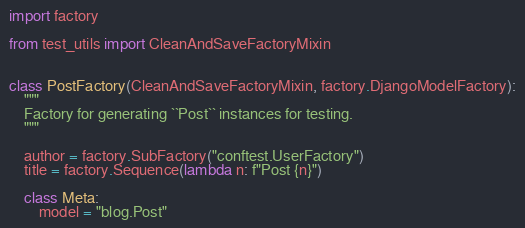<code> <loc_0><loc_0><loc_500><loc_500><_Python_>import factory

from test_utils import CleanAndSaveFactoryMixin


class PostFactory(CleanAndSaveFactoryMixin, factory.DjangoModelFactory):
    """
    Factory for generating ``Post`` instances for testing.
    """

    author = factory.SubFactory("conftest.UserFactory")
    title = factory.Sequence(lambda n: f"Post {n}")

    class Meta:
        model = "blog.Post"
</code> 